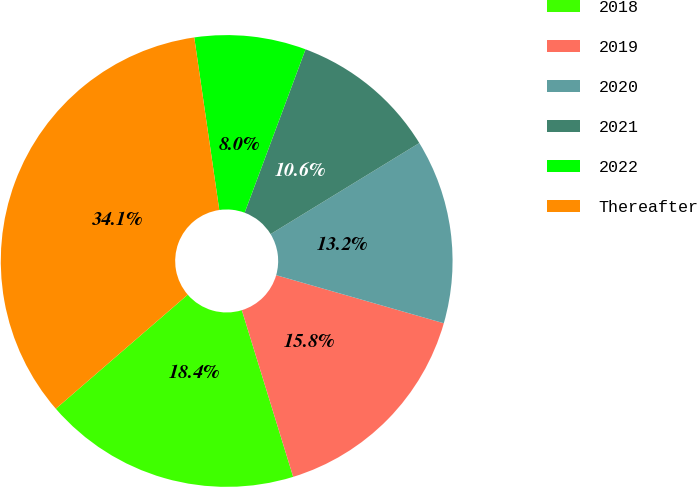Convert chart to OTSL. <chart><loc_0><loc_0><loc_500><loc_500><pie_chart><fcel>2018<fcel>2019<fcel>2020<fcel>2021<fcel>2022<fcel>Thereafter<nl><fcel>18.41%<fcel>15.8%<fcel>13.19%<fcel>10.58%<fcel>7.97%<fcel>34.06%<nl></chart> 